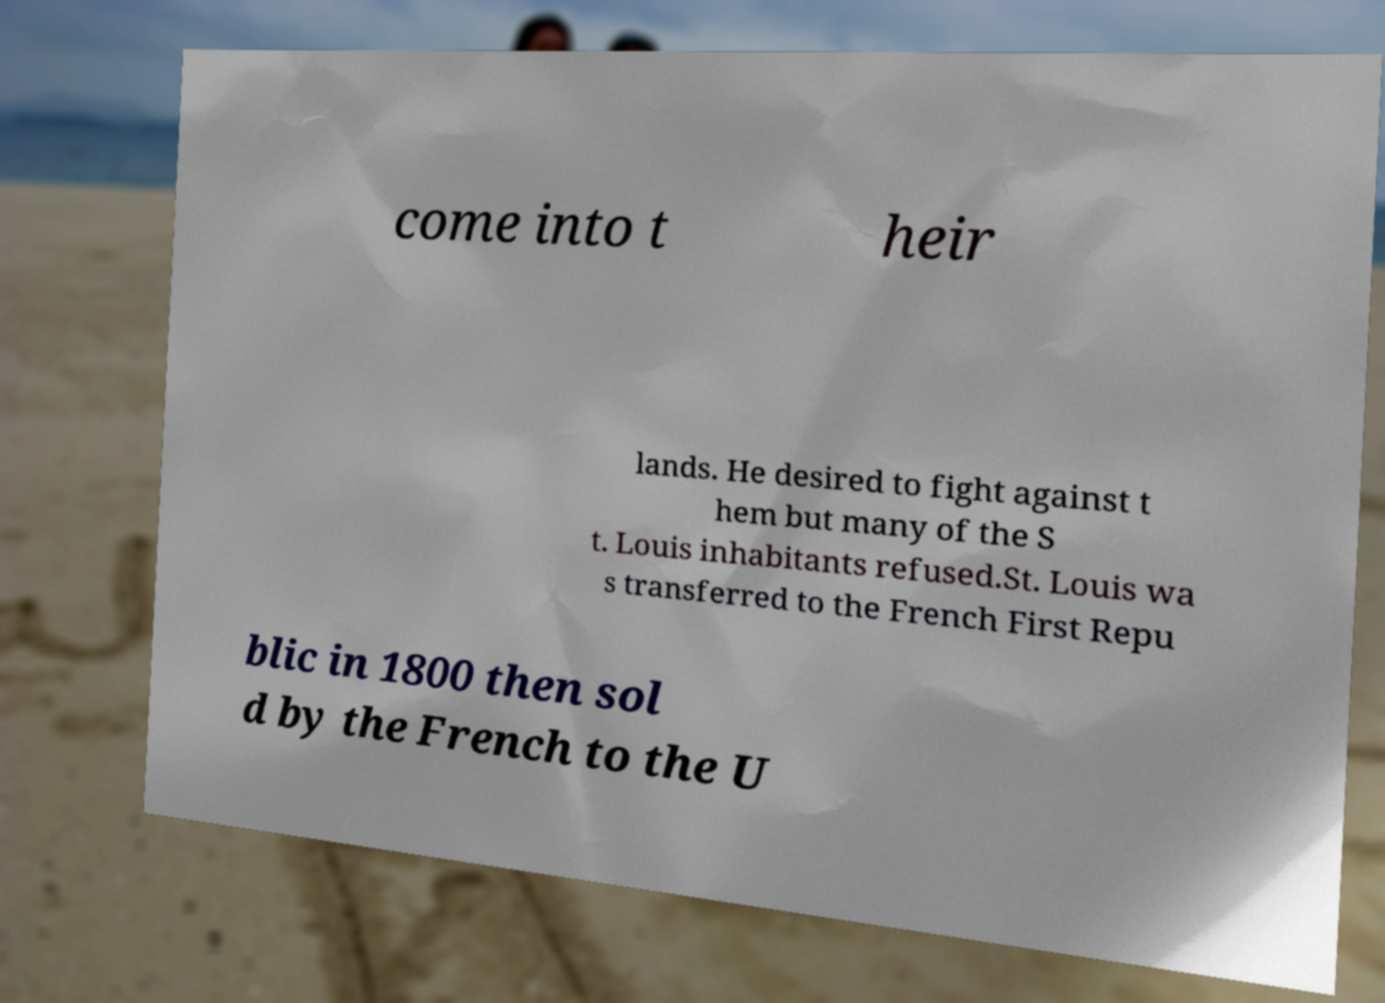Can you read and provide the text displayed in the image?This photo seems to have some interesting text. Can you extract and type it out for me? come into t heir lands. He desired to fight against t hem but many of the S t. Louis inhabitants refused.St. Louis wa s transferred to the French First Repu blic in 1800 then sol d by the French to the U 